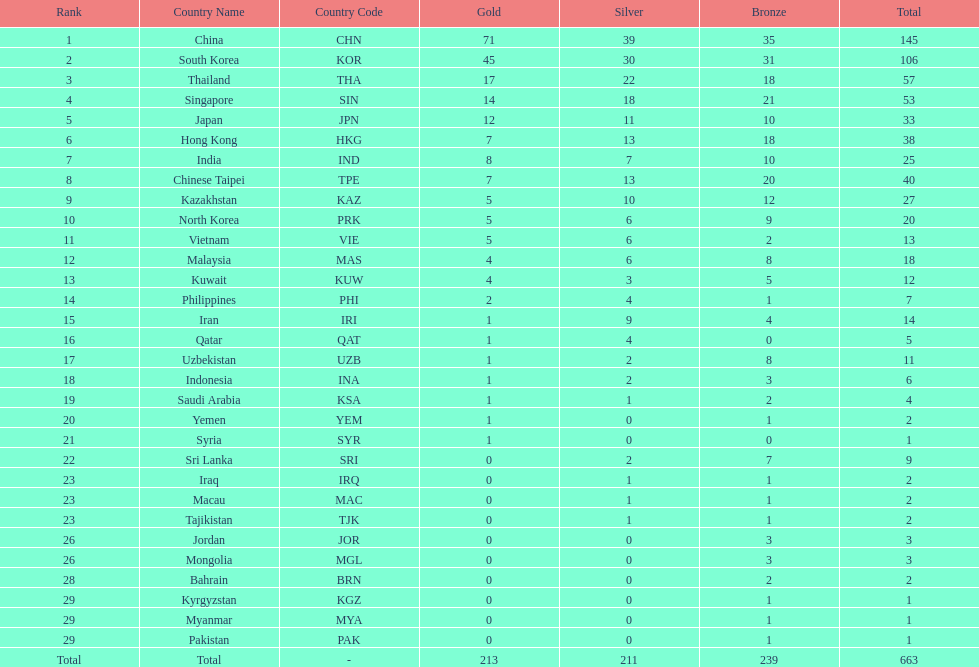How many more gold medals must qatar win before they can earn 12 gold medals? 11. 